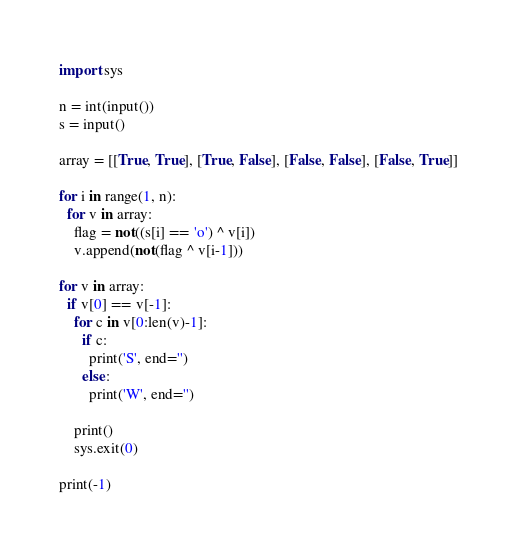<code> <loc_0><loc_0><loc_500><loc_500><_Python_>import sys

n = int(input())
s = input()

array = [[True, True], [True, False], [False, False], [False, True]]

for i in range(1, n):
  for v in array:
    flag = not((s[i] == 'o') ^ v[i])
    v.append(not(flag ^ v[i-1]))
    
for v in array:
  if v[0] == v[-1]:
    for c in v[0:len(v)-1]:
      if c:
        print('S', end='')
      else:
        print('W', end='')
        
    print()
    sys.exit(0)
    
print(-1)</code> 